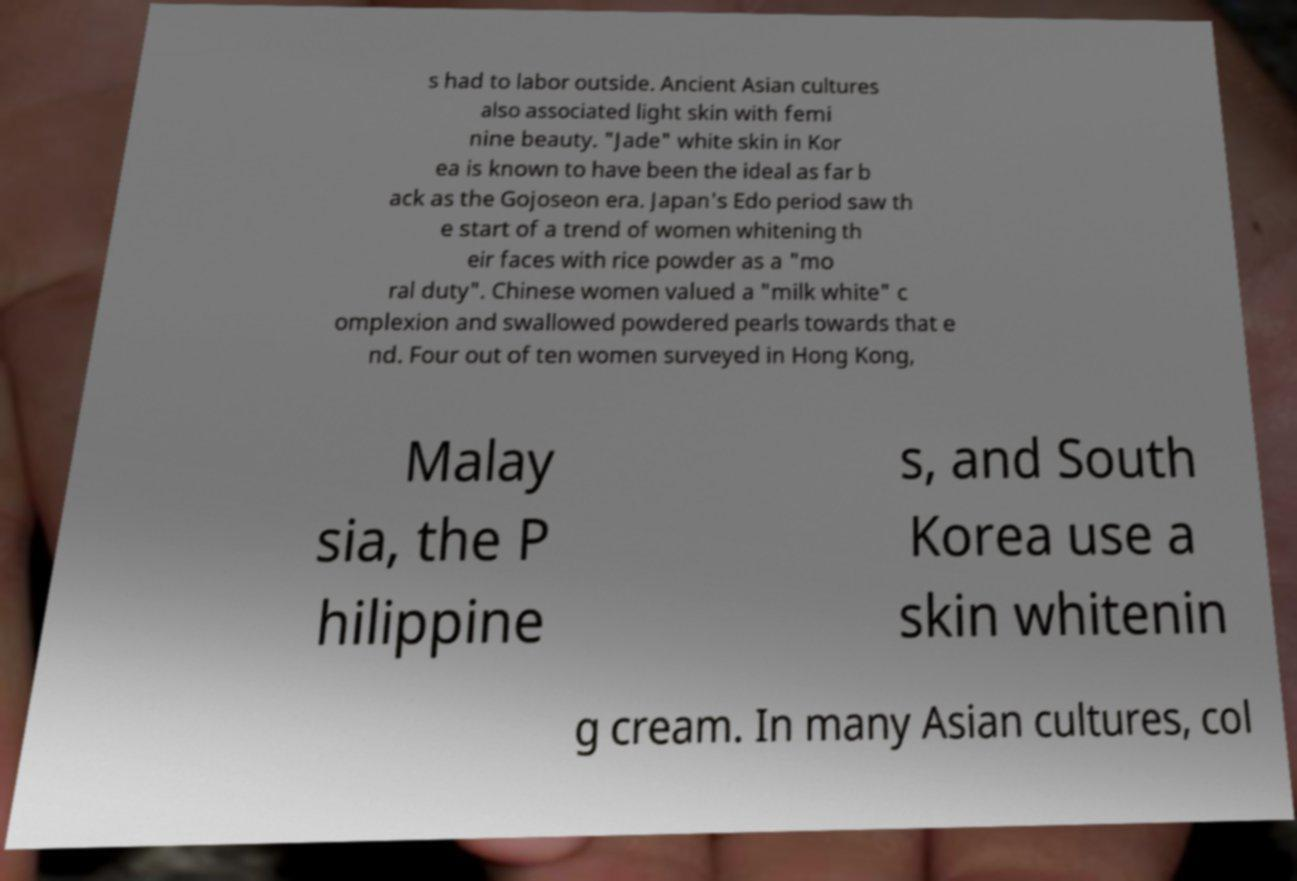For documentation purposes, I need the text within this image transcribed. Could you provide that? s had to labor outside. Ancient Asian cultures also associated light skin with femi nine beauty. "Jade" white skin in Kor ea is known to have been the ideal as far b ack as the Gojoseon era. Japan's Edo period saw th e start of a trend of women whitening th eir faces with rice powder as a "mo ral duty". Chinese women valued a "milk white" c omplexion and swallowed powdered pearls towards that e nd. Four out of ten women surveyed in Hong Kong, Malay sia, the P hilippine s, and South Korea use a skin whitenin g cream. In many Asian cultures, col 